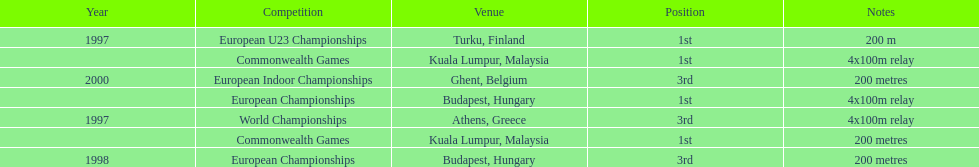How long was the sprint from the european indoor championships competition in 2000? 200 metres. 